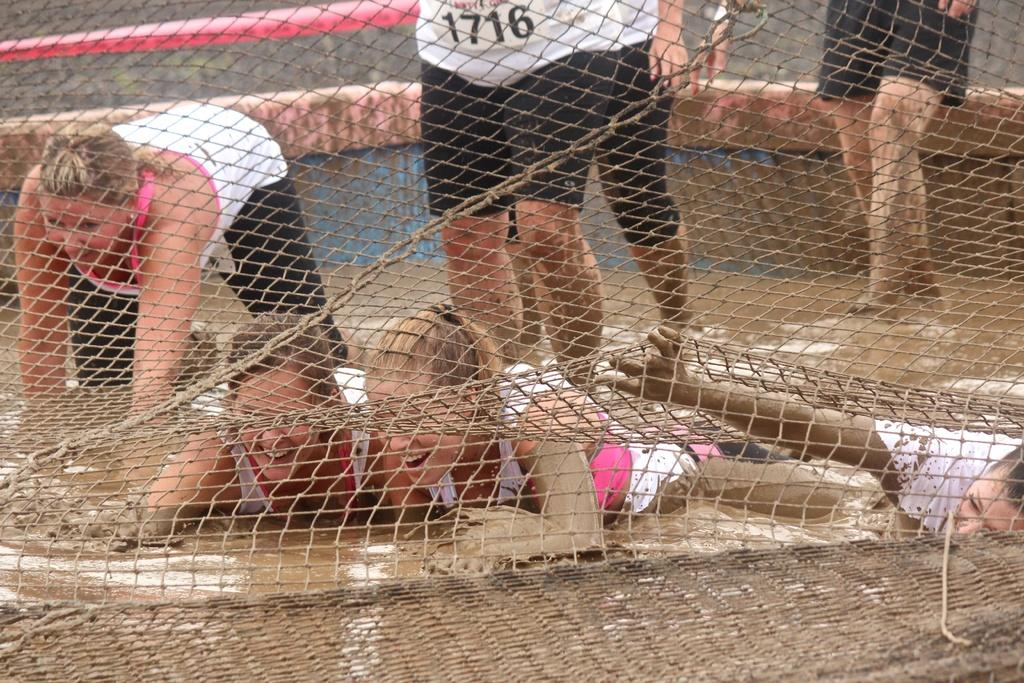How many people are in the image? There are people in the image, but the exact number is not specified. What are the people wearing? The people are wearing clothes. What are some of the positions the people are in? Some people are standing, and some are lying in the mud. What can be seen in the image besides the people? There is a net and mud in the image. What type of prose can be heard being read aloud in the image? There is no indication in the image that any prose is being read aloud. How many bats are present in the image? There are no bats present in the image. 